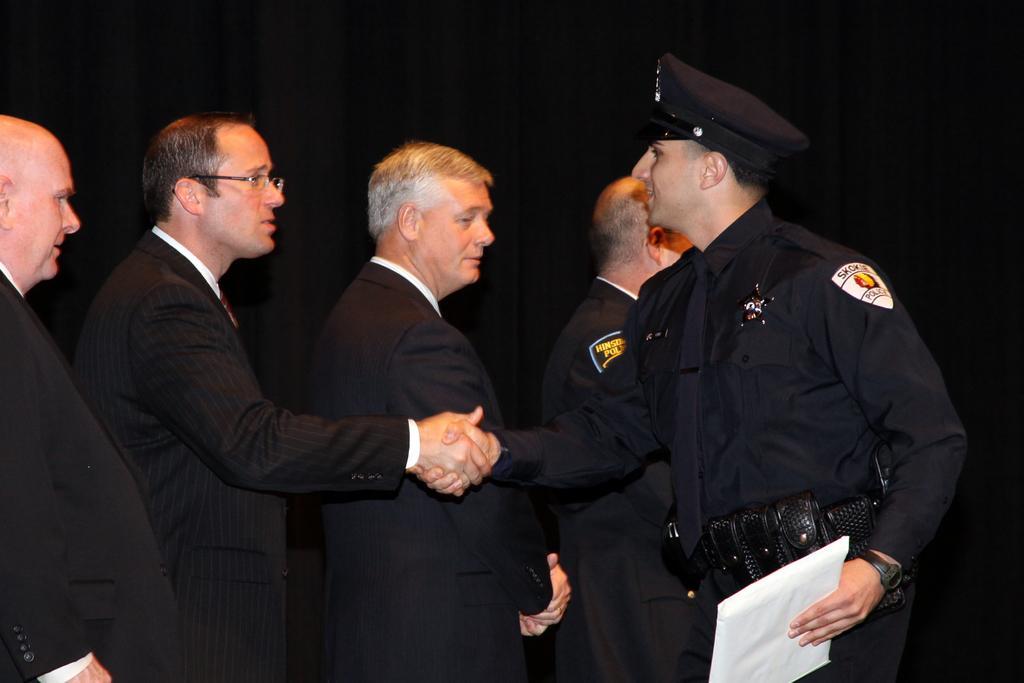Can you describe this image briefly? In this image there are four people standing in a line, in-front of them there is another man wearing uniform is standing and holding paper is giving shake to one of them. 